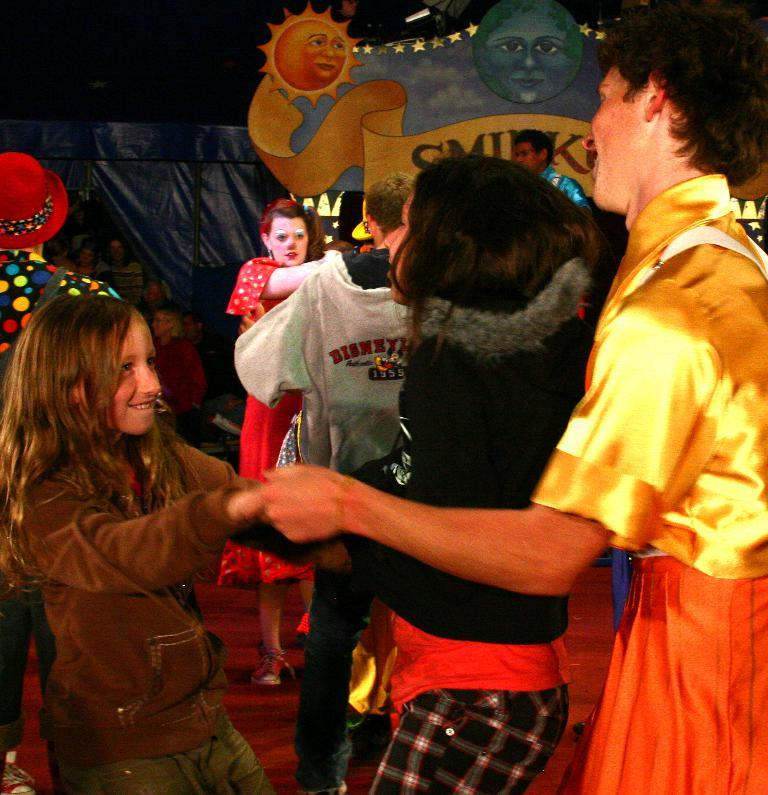Who or what can be seen in the image? There are people in the image. What can be seen in the background of the image? There is a blue hoarding in the background of the image. What type of metal basket is being used by the people in the image? There is no metal basket present in the image. What kind of pies are being served to the people in the image? There is no mention of pies in the image. 